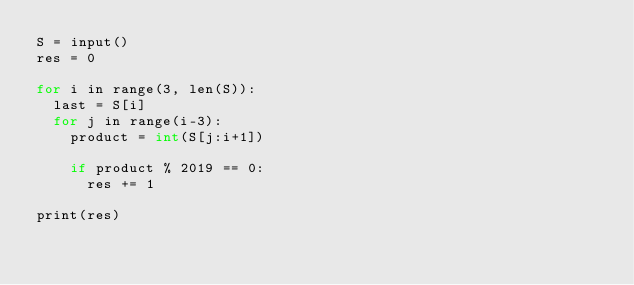Convert code to text. <code><loc_0><loc_0><loc_500><loc_500><_C_>S = input()
res = 0

for i in range(3, len(S)):
  last = S[i]
  for j in range(i-3):
    product = int(S[j:i+1])

    if product % 2019 == 0:
      res += 1

print(res)</code> 